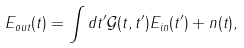<formula> <loc_0><loc_0><loc_500><loc_500>E _ { o u t } ( t ) = \int d t ^ { \prime } { \mathcal { G } } ( t , t ^ { \prime } ) E _ { i n } ( t ^ { \prime } ) + n ( t ) ,</formula> 